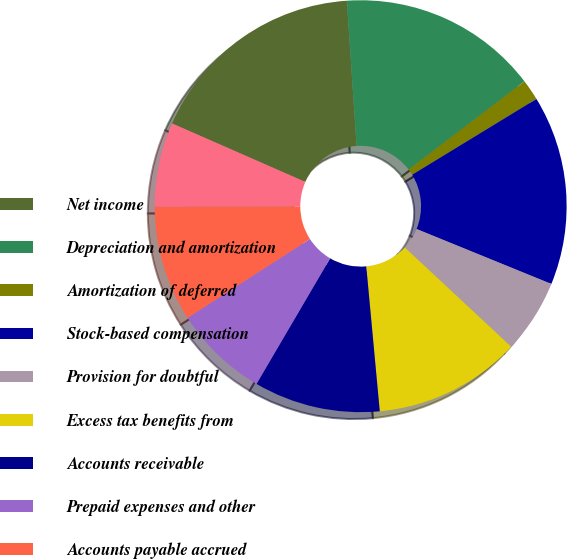Convert chart. <chart><loc_0><loc_0><loc_500><loc_500><pie_chart><fcel>Net income<fcel>Depreciation and amortization<fcel>Amortization of deferred<fcel>Stock-based compensation<fcel>Provision for doubtful<fcel>Excess tax benefits from<fcel>Accounts receivable<fcel>Prepaid expenses and other<fcel>Accounts payable accrued<fcel>Deferred revenue<nl><fcel>17.35%<fcel>15.7%<fcel>1.65%<fcel>14.88%<fcel>5.79%<fcel>11.57%<fcel>9.92%<fcel>7.44%<fcel>9.09%<fcel>6.61%<nl></chart> 